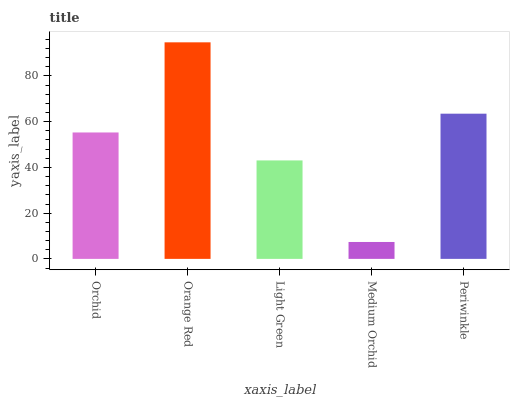Is Light Green the minimum?
Answer yes or no. No. Is Light Green the maximum?
Answer yes or no. No. Is Orange Red greater than Light Green?
Answer yes or no. Yes. Is Light Green less than Orange Red?
Answer yes or no. Yes. Is Light Green greater than Orange Red?
Answer yes or no. No. Is Orange Red less than Light Green?
Answer yes or no. No. Is Orchid the high median?
Answer yes or no. Yes. Is Orchid the low median?
Answer yes or no. Yes. Is Light Green the high median?
Answer yes or no. No. Is Periwinkle the low median?
Answer yes or no. No. 